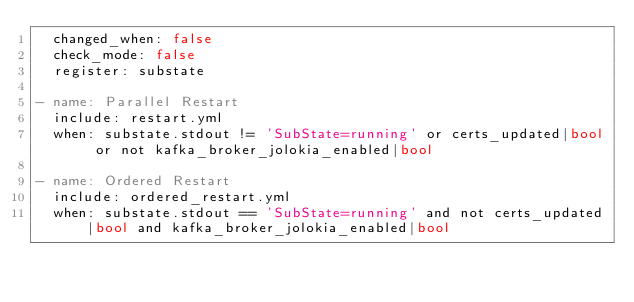<code> <loc_0><loc_0><loc_500><loc_500><_YAML_>  changed_when: false
  check_mode: false
  register: substate

- name: Parallel Restart
  include: restart.yml
  when: substate.stdout != 'SubState=running' or certs_updated|bool or not kafka_broker_jolokia_enabled|bool

- name: Ordered Restart
  include: ordered_restart.yml
  when: substate.stdout == 'SubState=running' and not certs_updated|bool and kafka_broker_jolokia_enabled|bool
</code> 